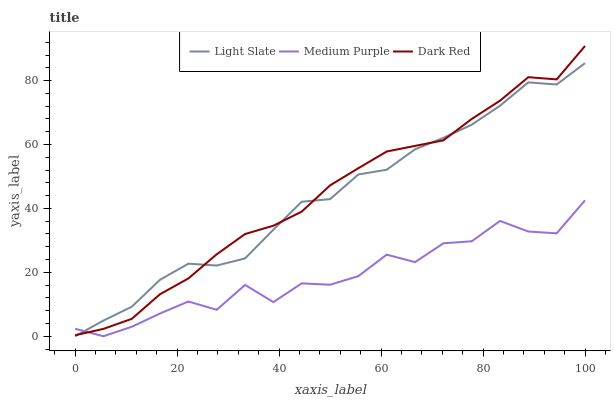Does Medium Purple have the minimum area under the curve?
Answer yes or no. Yes. Does Dark Red have the maximum area under the curve?
Answer yes or no. Yes. Does Dark Red have the minimum area under the curve?
Answer yes or no. No. Does Medium Purple have the maximum area under the curve?
Answer yes or no. No. Is Dark Red the smoothest?
Answer yes or no. Yes. Is Medium Purple the roughest?
Answer yes or no. Yes. Is Medium Purple the smoothest?
Answer yes or no. No. Is Dark Red the roughest?
Answer yes or no. No. Does Light Slate have the lowest value?
Answer yes or no. Yes. Does Dark Red have the lowest value?
Answer yes or no. No. Does Dark Red have the highest value?
Answer yes or no. Yes. Does Medium Purple have the highest value?
Answer yes or no. No. Does Light Slate intersect Medium Purple?
Answer yes or no. Yes. Is Light Slate less than Medium Purple?
Answer yes or no. No. Is Light Slate greater than Medium Purple?
Answer yes or no. No. 